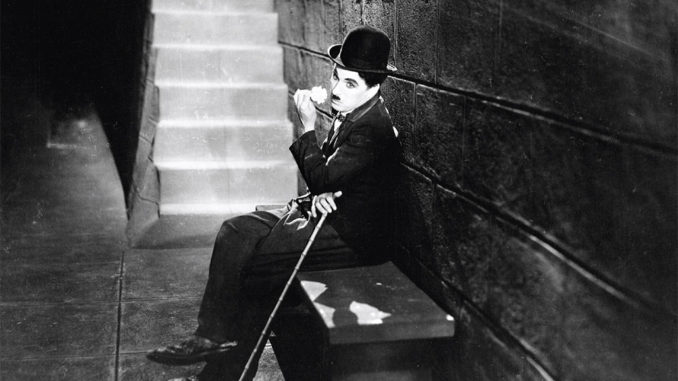Let’s create a very realistic scenario related to the image. Chaplin's Tramp, sitting alone on the bench, appears deep in thought. In this scene, he's taking a quiet moment to rest after a long day's wander through the bustling city. The stone bench, a momentary haven, offers respite from his ceaseless quest for work and sustenance. As the camera zooms in, the subtle weariness etched on his face reveals the countless struggles he's endured, yet his resilient spirit remains unbroken. This image, though seemingly serene, speaks to the everyday challenges faced by those living on the margins of society during the early 20th century, rendering the Tramp’s hopeful perseverance all the more poignant. 